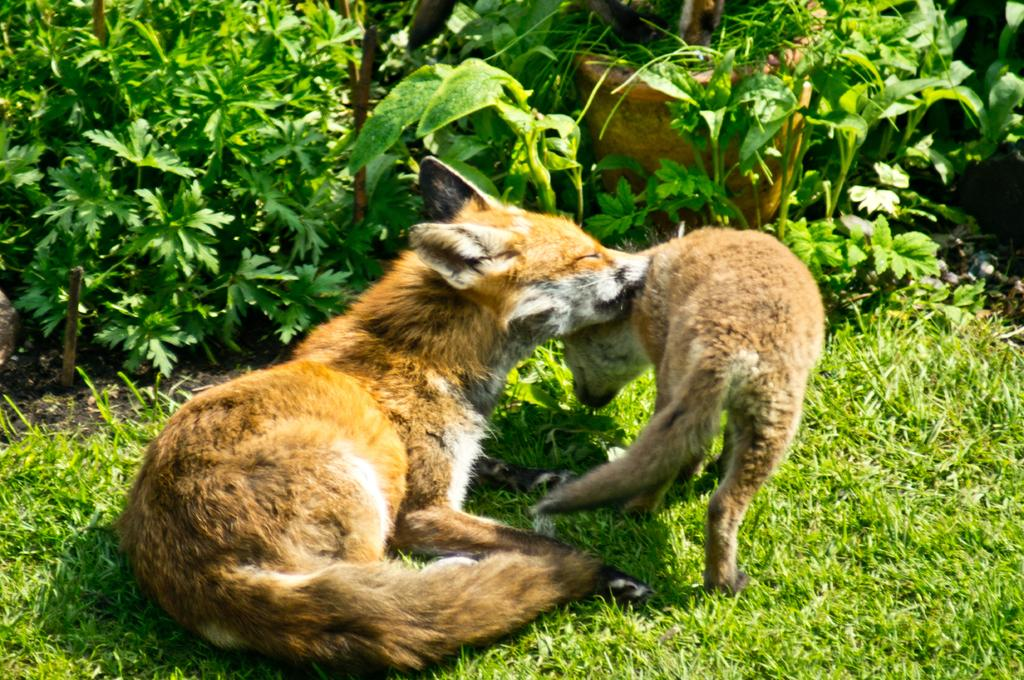What types of living organisms are in the image? There are two animals in the image. Where are the animals located? The animals are on the grass. What can be seen in the background of the image? There are plants and a pot in the background of the image. What type of writing can be seen on the animals in the image? There is no writing present on the animals in the image. Does the existence of the animals in the image cause any pain? The image does not provide any information about the animals experiencing pain, and it is not appropriate to assume or speculate about their emotional or physical state. 